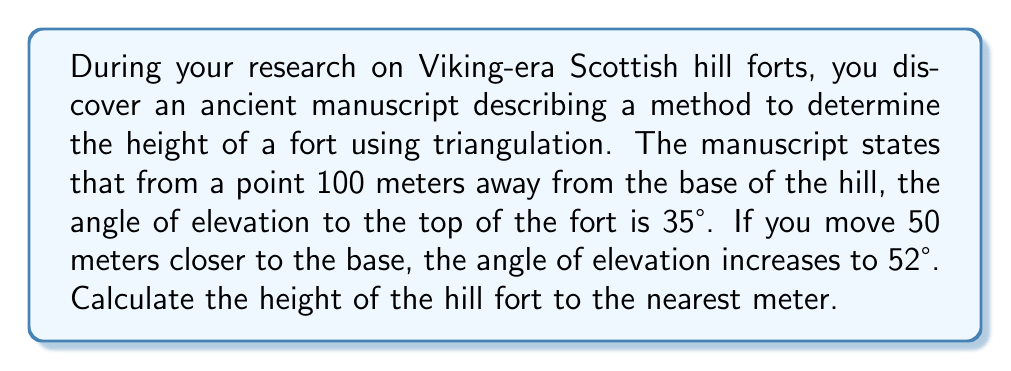Can you answer this question? Let's approach this step-by-step using trigonometry:

1) Let's define our variables:
   $h$ = height of the hill fort
   $x$ = distance from the closer observation point to the base of the hill

2) We can set up two equations using tangent:

   From the farther point: $\tan(35°) = \frac{h}{100}$
   From the closer point: $\tan(52°) = \frac{h}{x}$

3) We know that the difference between these two distances is 50m, so:
   $100 - x = 50$
   $x = 50$

4) Now we can solve for $h$ using either equation. Let's use the second one:

   $\tan(52°) = \frac{h}{50}$
   $h = 50 \tan(52°)$

5) Calculate:
   $h = 50 \times \tan(52°)$
   $h = 50 \times 1.2799$
   $h = 63.995$ meters

6) Rounding to the nearest meter:
   $h \approx 64$ meters

Here's a visual representation of the problem:

[asy]
import geometry;

size(200);

pair A = (0,0);
pair B = (50,0);
pair C = (100,0);
pair D = (0,64);

draw(A--C);
draw(A--D);
draw(B--D);
draw(C--D);

label("100m", (50,-5), S);
label("50m", (75,-5), S);
label("64m", (-5,32), W);
label("35°", (95,10), E);
label("52°", (45,15), E);

dot("A", A, SW);
dot("B", B, S);
dot("C", C, SE);
dot("D", D, N);
[/asy]
Answer: The height of the hill fort is approximately 64 meters. 